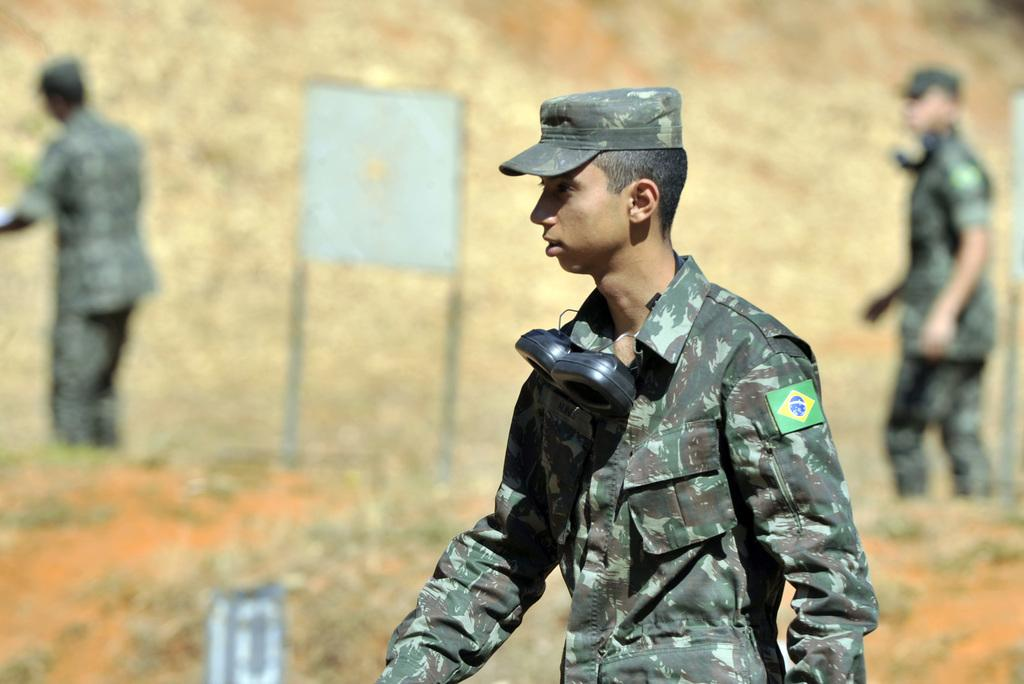How many people are present in the image? There are three people in the image. What are the people wearing? The people are wearing army dress. What else can be seen in the image besides the people? There is a sign board in the image. Can you describe the quality of the image? The image is blurry. What level of difficulty is the beginner thrill ride at the school in the image? There is no mention of a school, a beginner thrill ride, or any ride in the image. The image features three people wearing army dress and a sign board. 